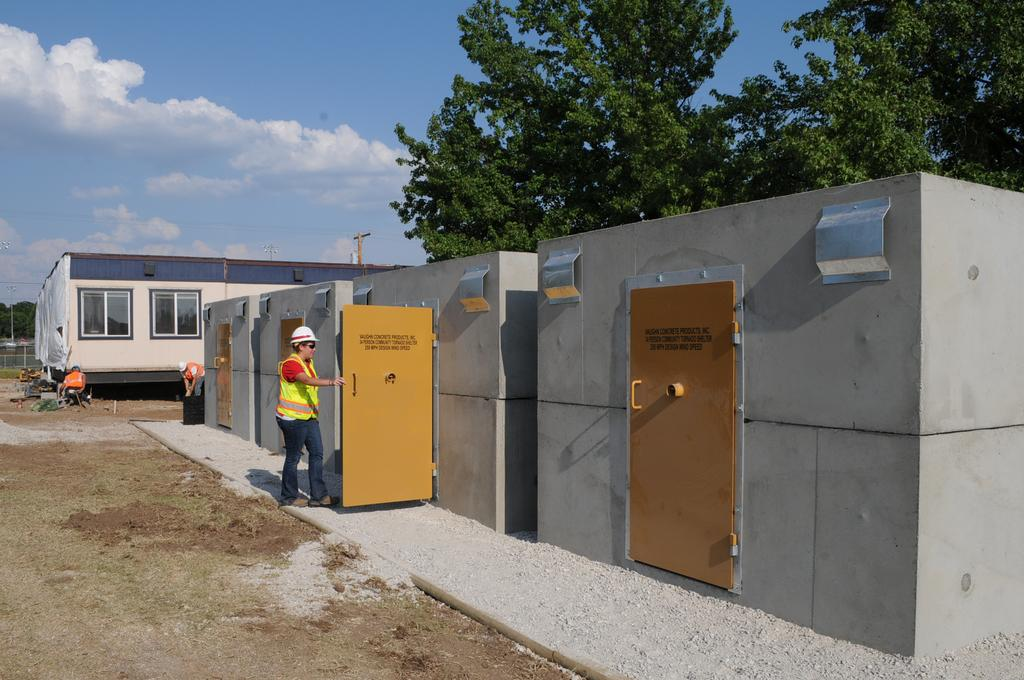What is the man in the image wearing? The man is wearing a safety dress and helmet. What might the man be doing in the image? The man is entering a room. What can be seen in the background of the image? There are trees and a building visible in the image. What is visible in the sky in the image? The sky is visible in the image, and clouds are present. What type of food is the man eating in the image? There is no food present in the image, and the man is not eating anything. How many girls are visible in the image? There are no girls present in the image; it only features a man. 